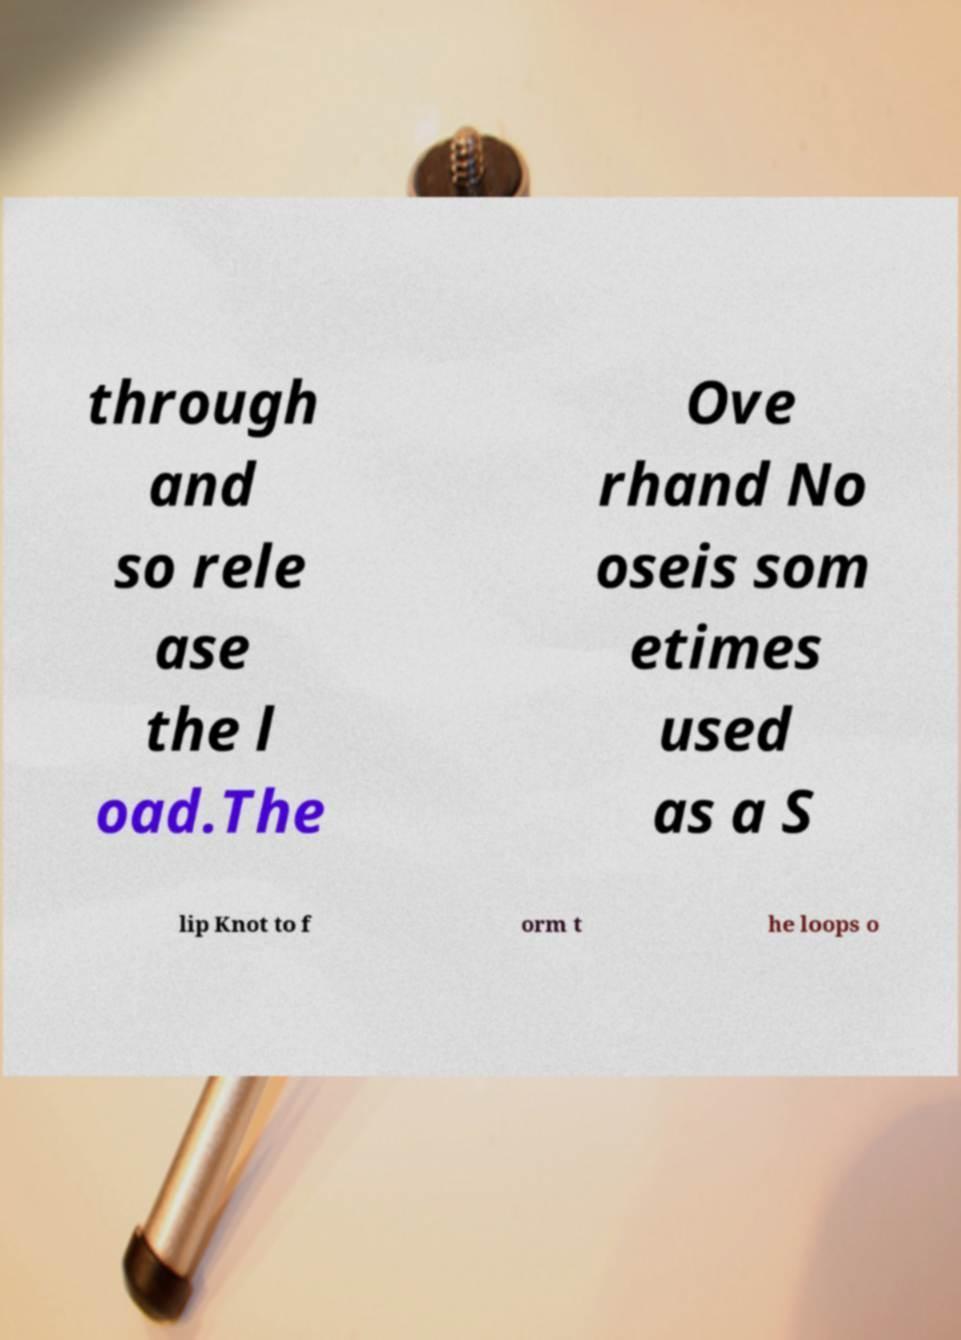Could you assist in decoding the text presented in this image and type it out clearly? through and so rele ase the l oad.The Ove rhand No oseis som etimes used as a S lip Knot to f orm t he loops o 